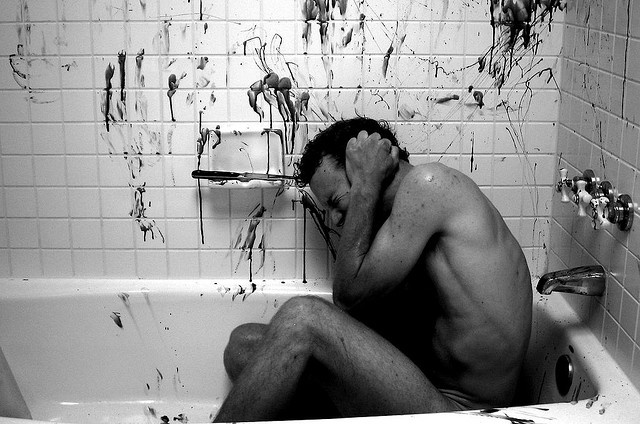Describe the objects in this image and their specific colors. I can see people in gray, black, and lightgray tones and knife in gray, black, darkgray, and lightgray tones in this image. 